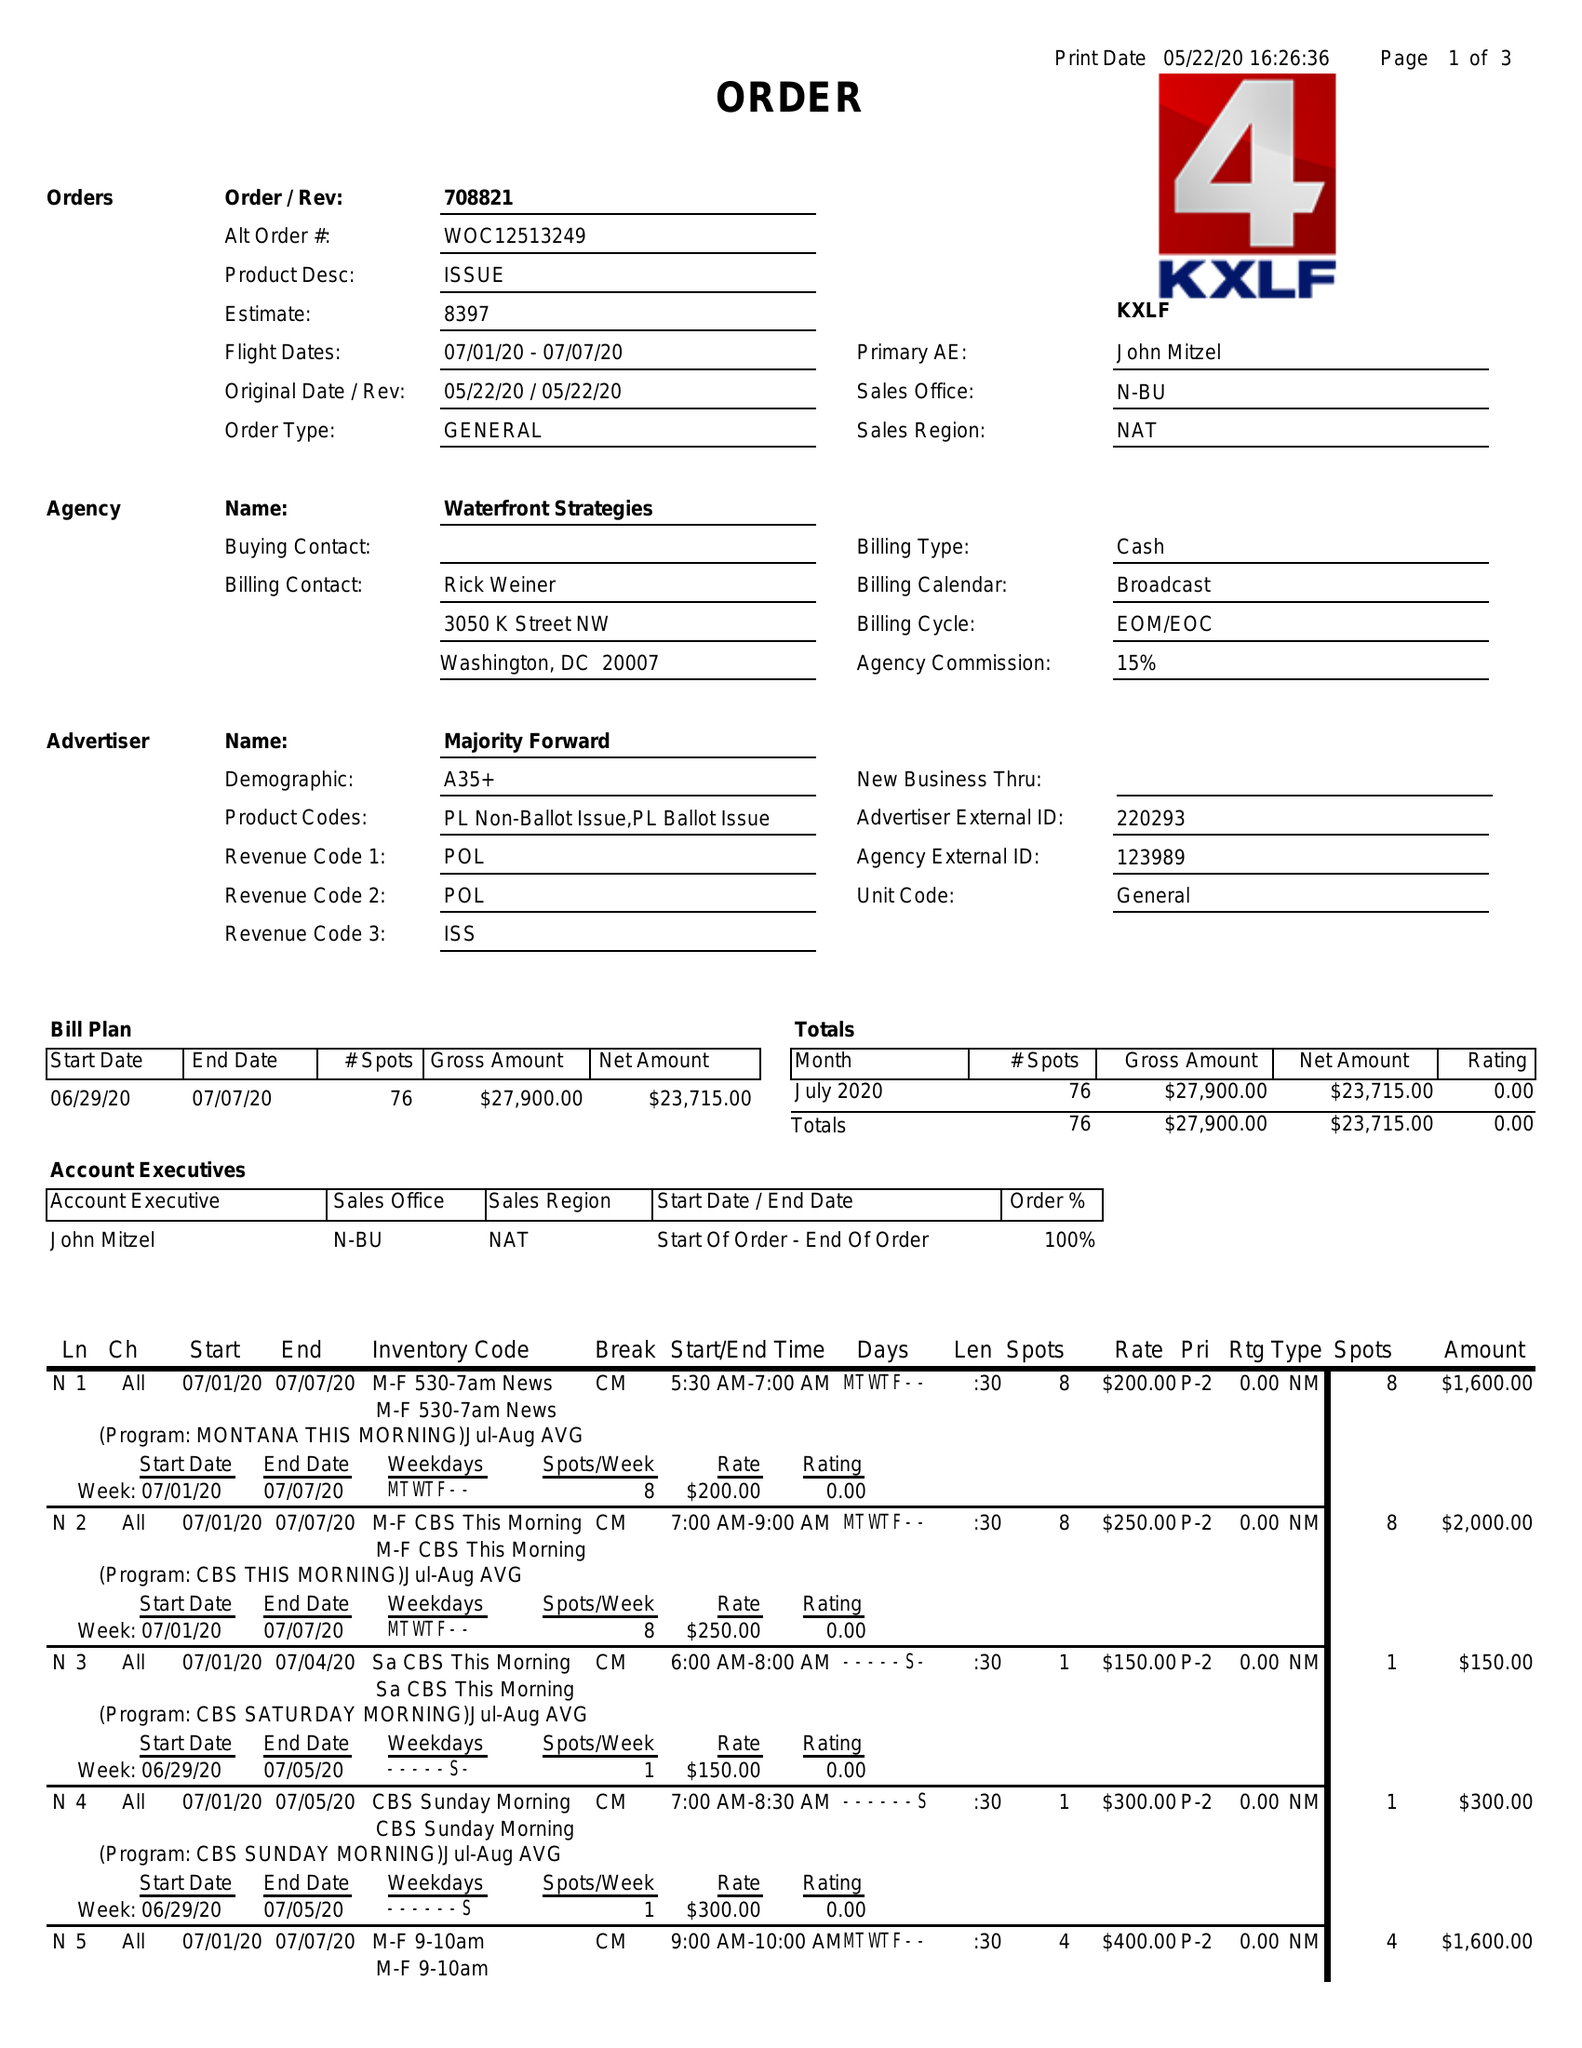What is the value for the flight_from?
Answer the question using a single word or phrase. 07/01/20 